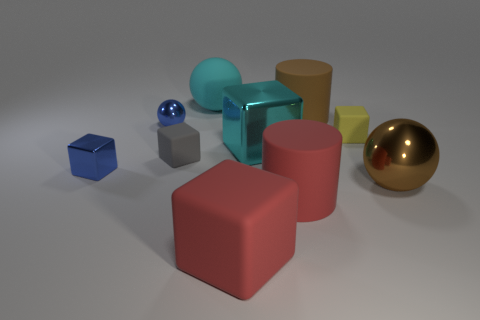Subtract all cylinders. How many objects are left? 8 Subtract all large red matte cylinders. Subtract all rubber objects. How many objects are left? 3 Add 8 brown rubber objects. How many brown rubber objects are left? 9 Add 8 big balls. How many big balls exist? 10 Subtract all brown cylinders. How many cylinders are left? 1 Subtract all large balls. How many balls are left? 1 Subtract 1 brown cylinders. How many objects are left? 9 Subtract 1 cylinders. How many cylinders are left? 1 Subtract all brown balls. Subtract all yellow blocks. How many balls are left? 2 Subtract all cyan balls. How many red cubes are left? 1 